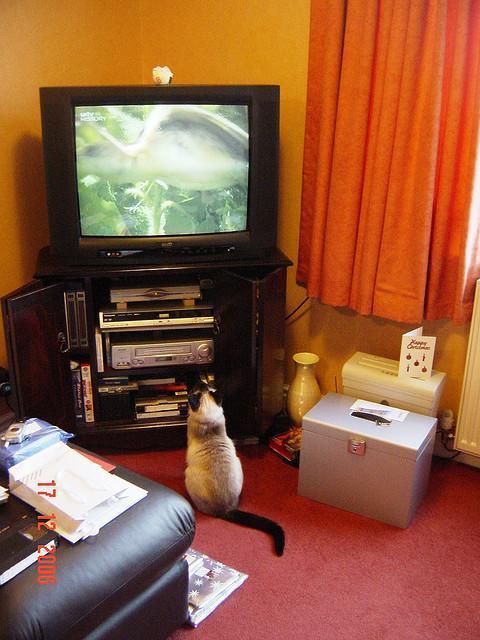How many cats are there?
Give a very brief answer. 1. How many tvs are there?
Give a very brief answer. 2. 